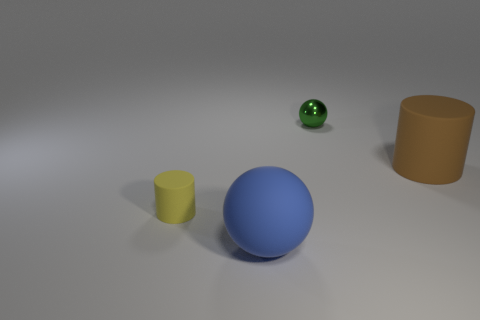Can you describe the setting or environment the objects are in? The objects are situated on what appears to be a flat, uniform surface with a neutral gray tone, which resembles a minimalistic studio setting designed to highlight the objects without any distraction from the background. The soft shadows beneath the objects suggest a diffused lighting typical of indoor photography or a controlled studio environment. 